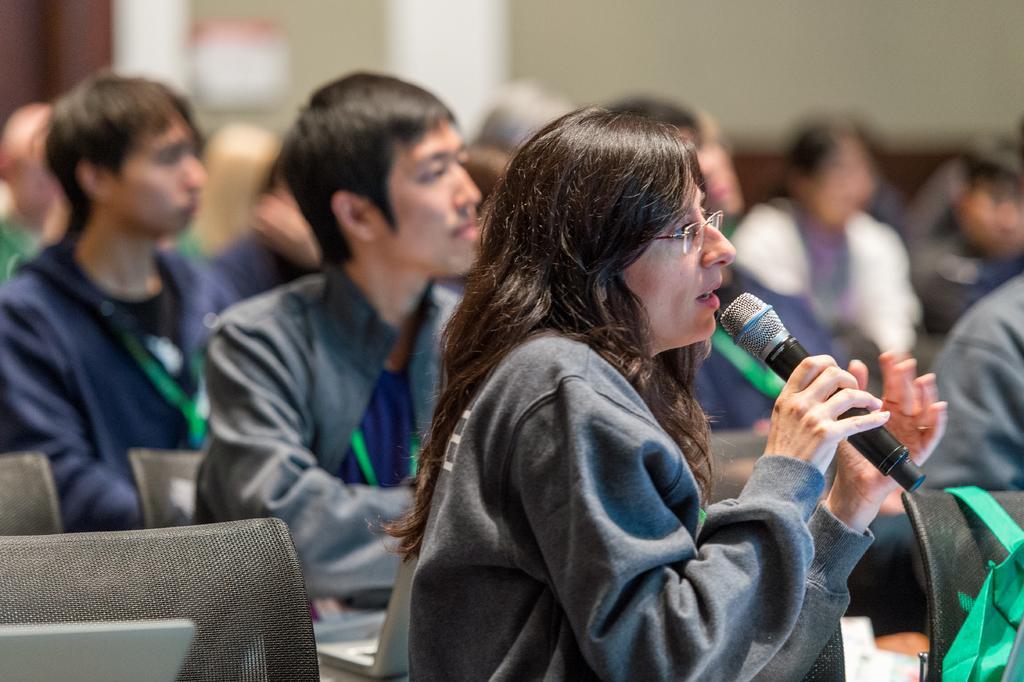Describe this image in one or two sentences. A woman is holding a mic, wearing specs and is talking. In the background there are many persons sitting. There are many chairs. 